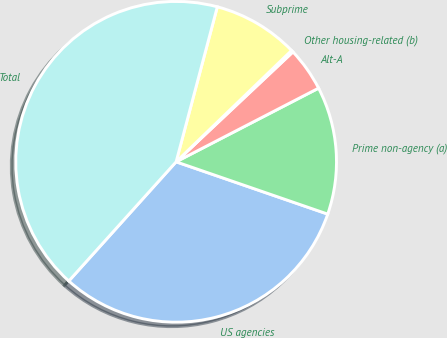Convert chart to OTSL. <chart><loc_0><loc_0><loc_500><loc_500><pie_chart><fcel>US agencies<fcel>Prime non-agency (a)<fcel>Alt-A<fcel>Other housing-related (b)<fcel>Subprime<fcel>Total<nl><fcel>31.38%<fcel>12.88%<fcel>4.42%<fcel>0.2%<fcel>8.65%<fcel>42.47%<nl></chart> 